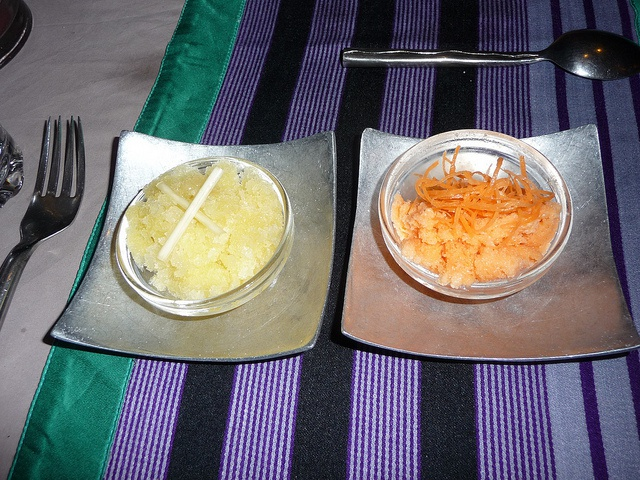Describe the objects in this image and their specific colors. I can see dining table in black, gray, darkgray, and teal tones, bowl in black, orange, lightgray, and darkgray tones, bowl in black, khaki, ivory, and darkgray tones, fork in black and gray tones, and spoon in black, gray, white, and darkgray tones in this image. 